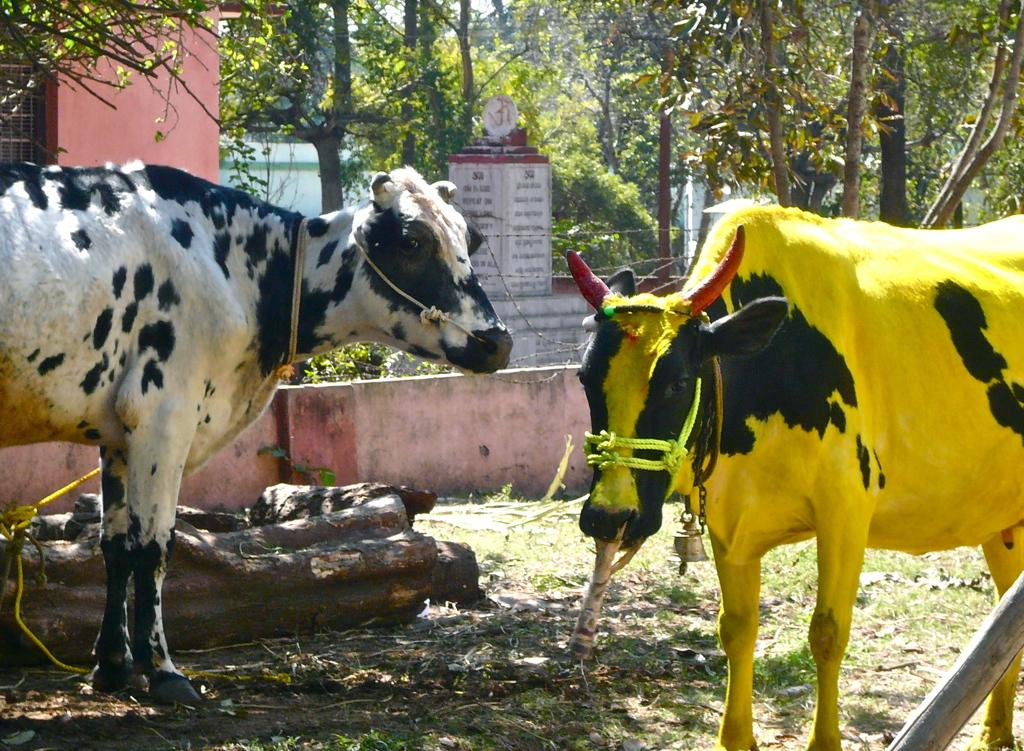What type of animals can be seen in the image? There are cows in the image. What other natural elements are present in the image? There are trees in the image. Can you describe any unique features of the trees? Tree bark is visible in the image. What is written on in the image? There is text on stones in the image. What is the cow wearing in the image? One cow has a bell around its neck. What type of structures can be seen in the image? There are houses in the image. What type of root can be seen growing from the cow's neck in the image? There is no root growing from the cow's neck in the image; it has a bell around its neck. Can you describe the street where the cows are walking in the image? There is no street present in the image, nor are the cows walking. 